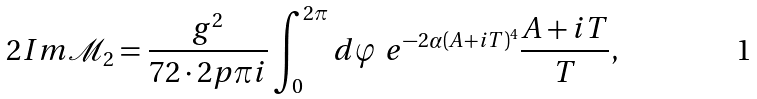Convert formula to latex. <formula><loc_0><loc_0><loc_500><loc_500>2 I m \mathcal { M } _ { 2 } = \frac { g ^ { 2 } } { 7 2 \cdot 2 p \pi i } \int _ { 0 } ^ { 2 \pi } d \varphi \ e ^ { - 2 \alpha ( A + i T ) ^ { 4 } } \frac { A + i T } { T } ,</formula> 